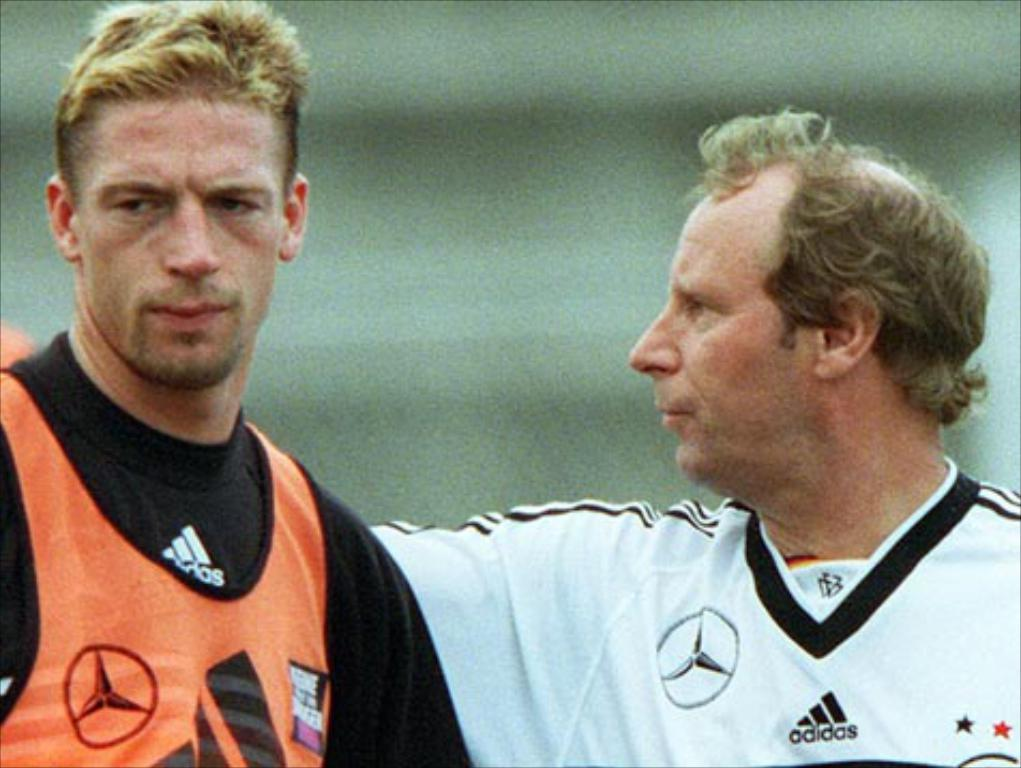<image>
Offer a succinct explanation of the picture presented. Two men looking rough with one of them wearing an adidas shirt. 